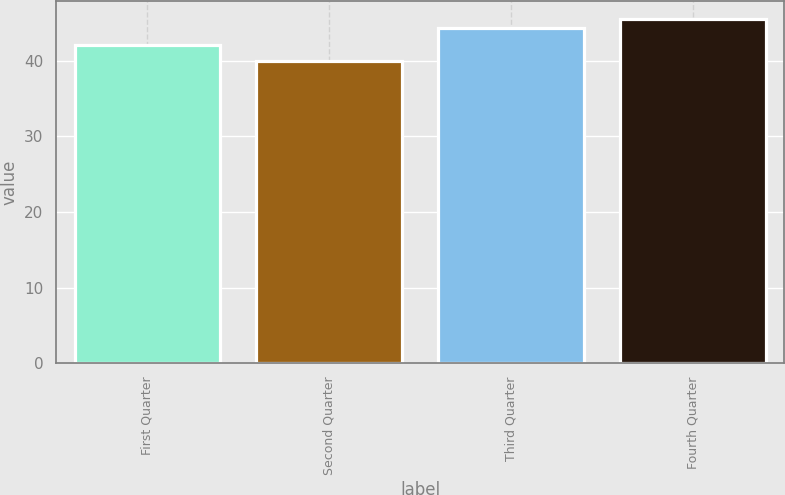<chart> <loc_0><loc_0><loc_500><loc_500><bar_chart><fcel>First Quarter<fcel>Second Quarter<fcel>Third Quarter<fcel>Fourth Quarter<nl><fcel>42.06<fcel>39.98<fcel>44.32<fcel>45.55<nl></chart> 